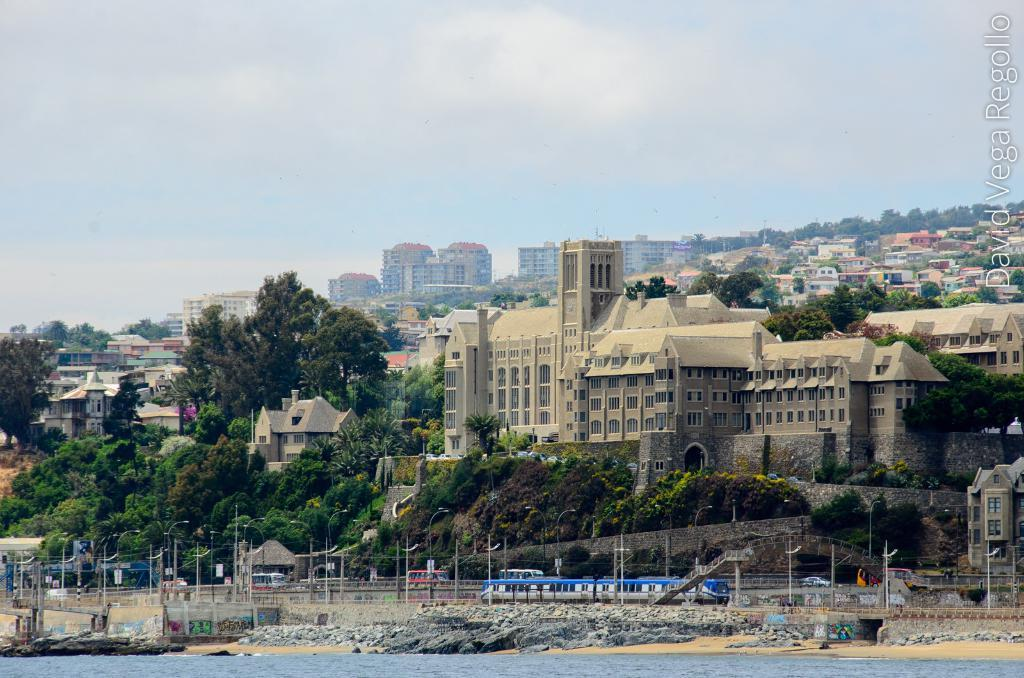What is visible in the image? Water, vehicles, trees, buildings, and clouds are visible in the image. What type of vehicles can be seen on the road? The vehicles on the road cannot be identified specifically, but they are visible in the image. What is the background of the image composed of? The background of the image includes trees, buildings, and clouds. How is the sky depicted in the image? The sky is depicted with clouds in the background of the image. How many balls are being used by the trees in the image? There are no balls present in the image, as it features water, vehicles, trees, buildings, and clouds. What type of zephyr can be seen blowing through the buildings in the image? There is no mention of a zephyr or any wind in the image; it only shows water, vehicles, trees, buildings, and clouds. 